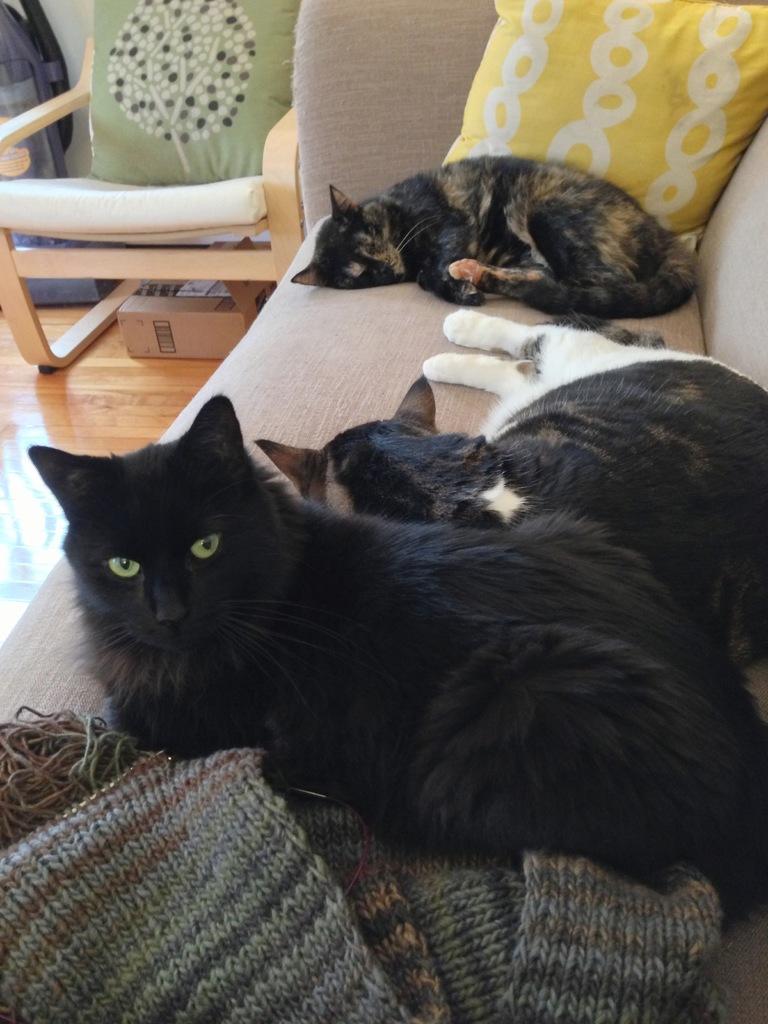How would you summarize this image in a sentence or two? In this picture there are three cats lying on a sofa. Towards the left top there is a chair with green pillow. 